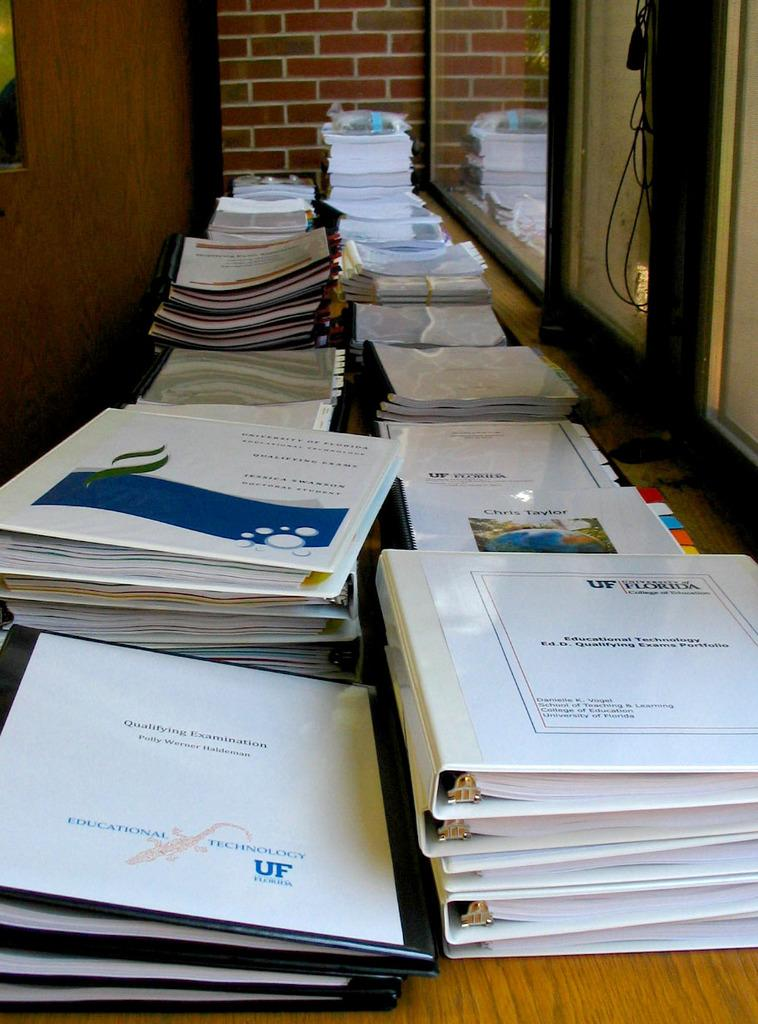<image>
Summarize the visual content of the image. Lots of binders are stacked on a table and one has Educational Technology written on the front. 